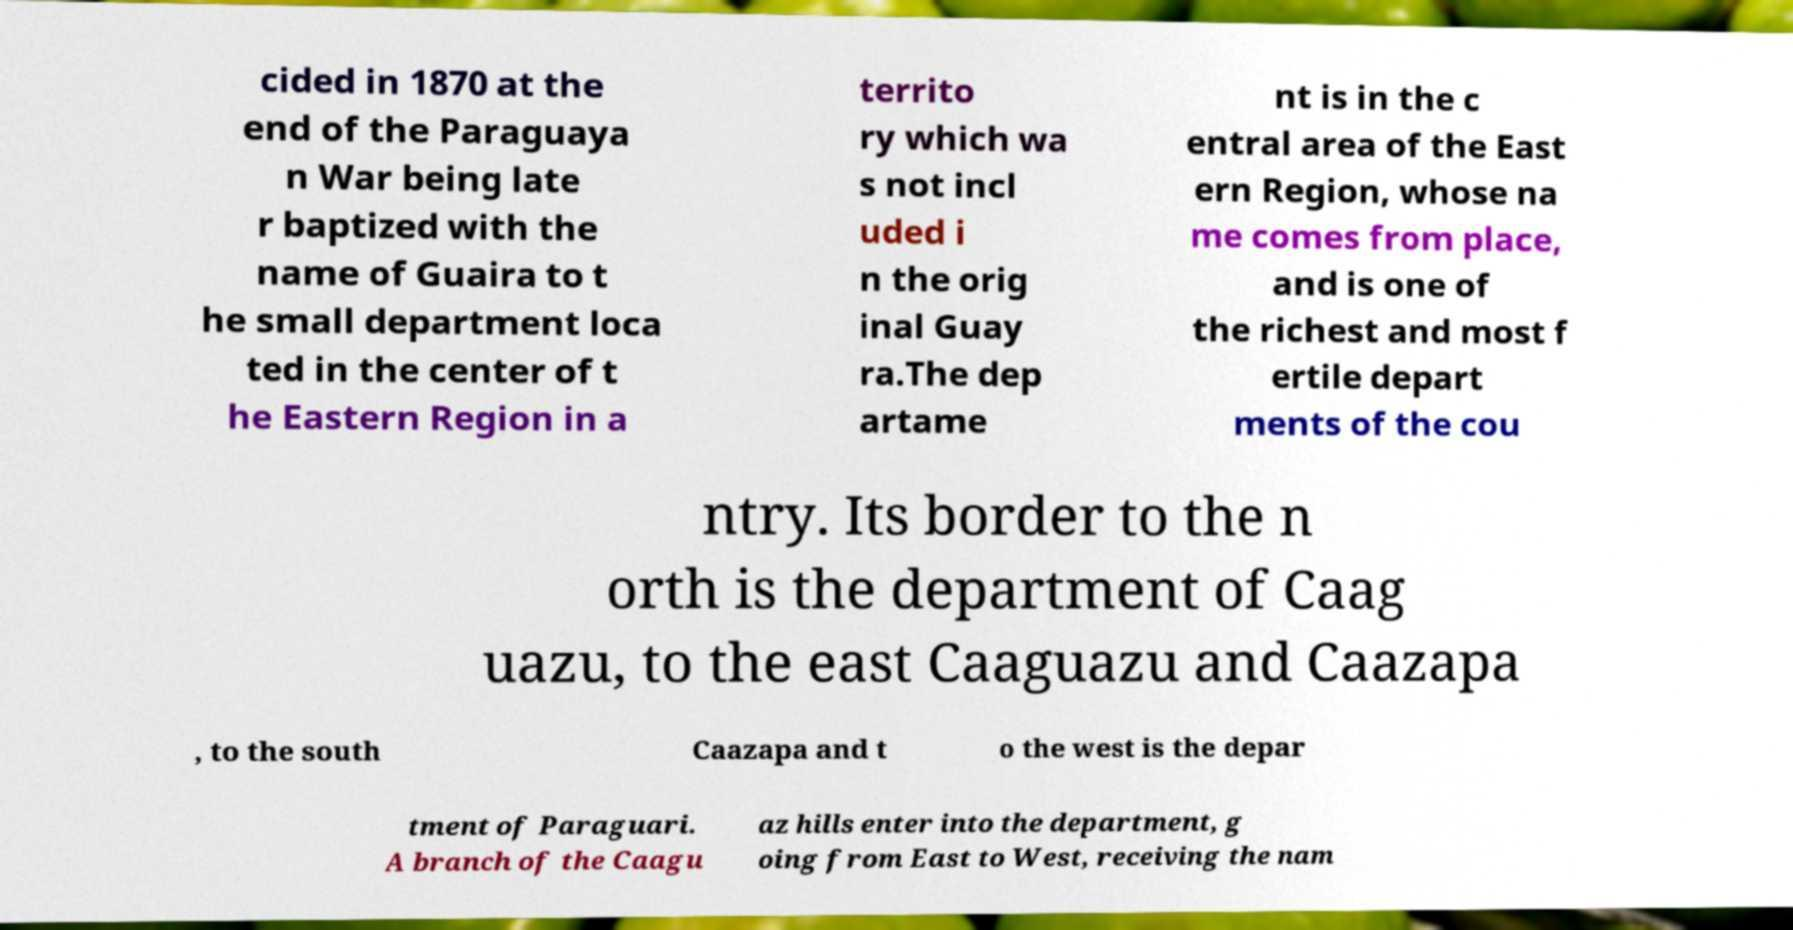Can you read and provide the text displayed in the image?This photo seems to have some interesting text. Can you extract and type it out for me? cided in 1870 at the end of the Paraguaya n War being late r baptized with the name of Guaira to t he small department loca ted in the center of t he Eastern Region in a territo ry which wa s not incl uded i n the orig inal Guay ra.The dep artame nt is in the c entral area of the East ern Region, whose na me comes from place, and is one of the richest and most f ertile depart ments of the cou ntry. Its border to the n orth is the department of Caag uazu, to the east Caaguazu and Caazapa , to the south Caazapa and t o the west is the depar tment of Paraguari. A branch of the Caagu az hills enter into the department, g oing from East to West, receiving the nam 